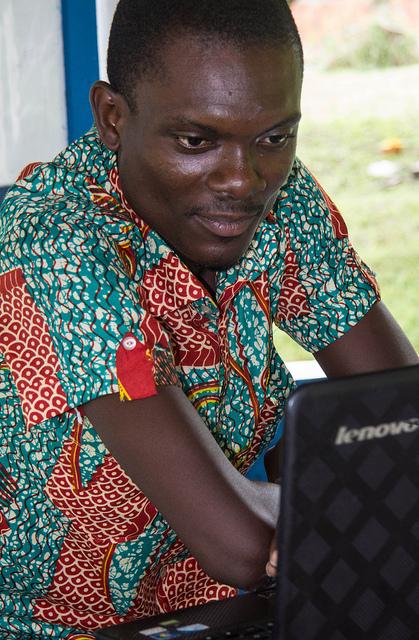Are the man's eyes open?
Be succinct. Yes. Is the laptop on?
Answer briefly. Yes. Is the man smiling?
Concise answer only. Yes. 